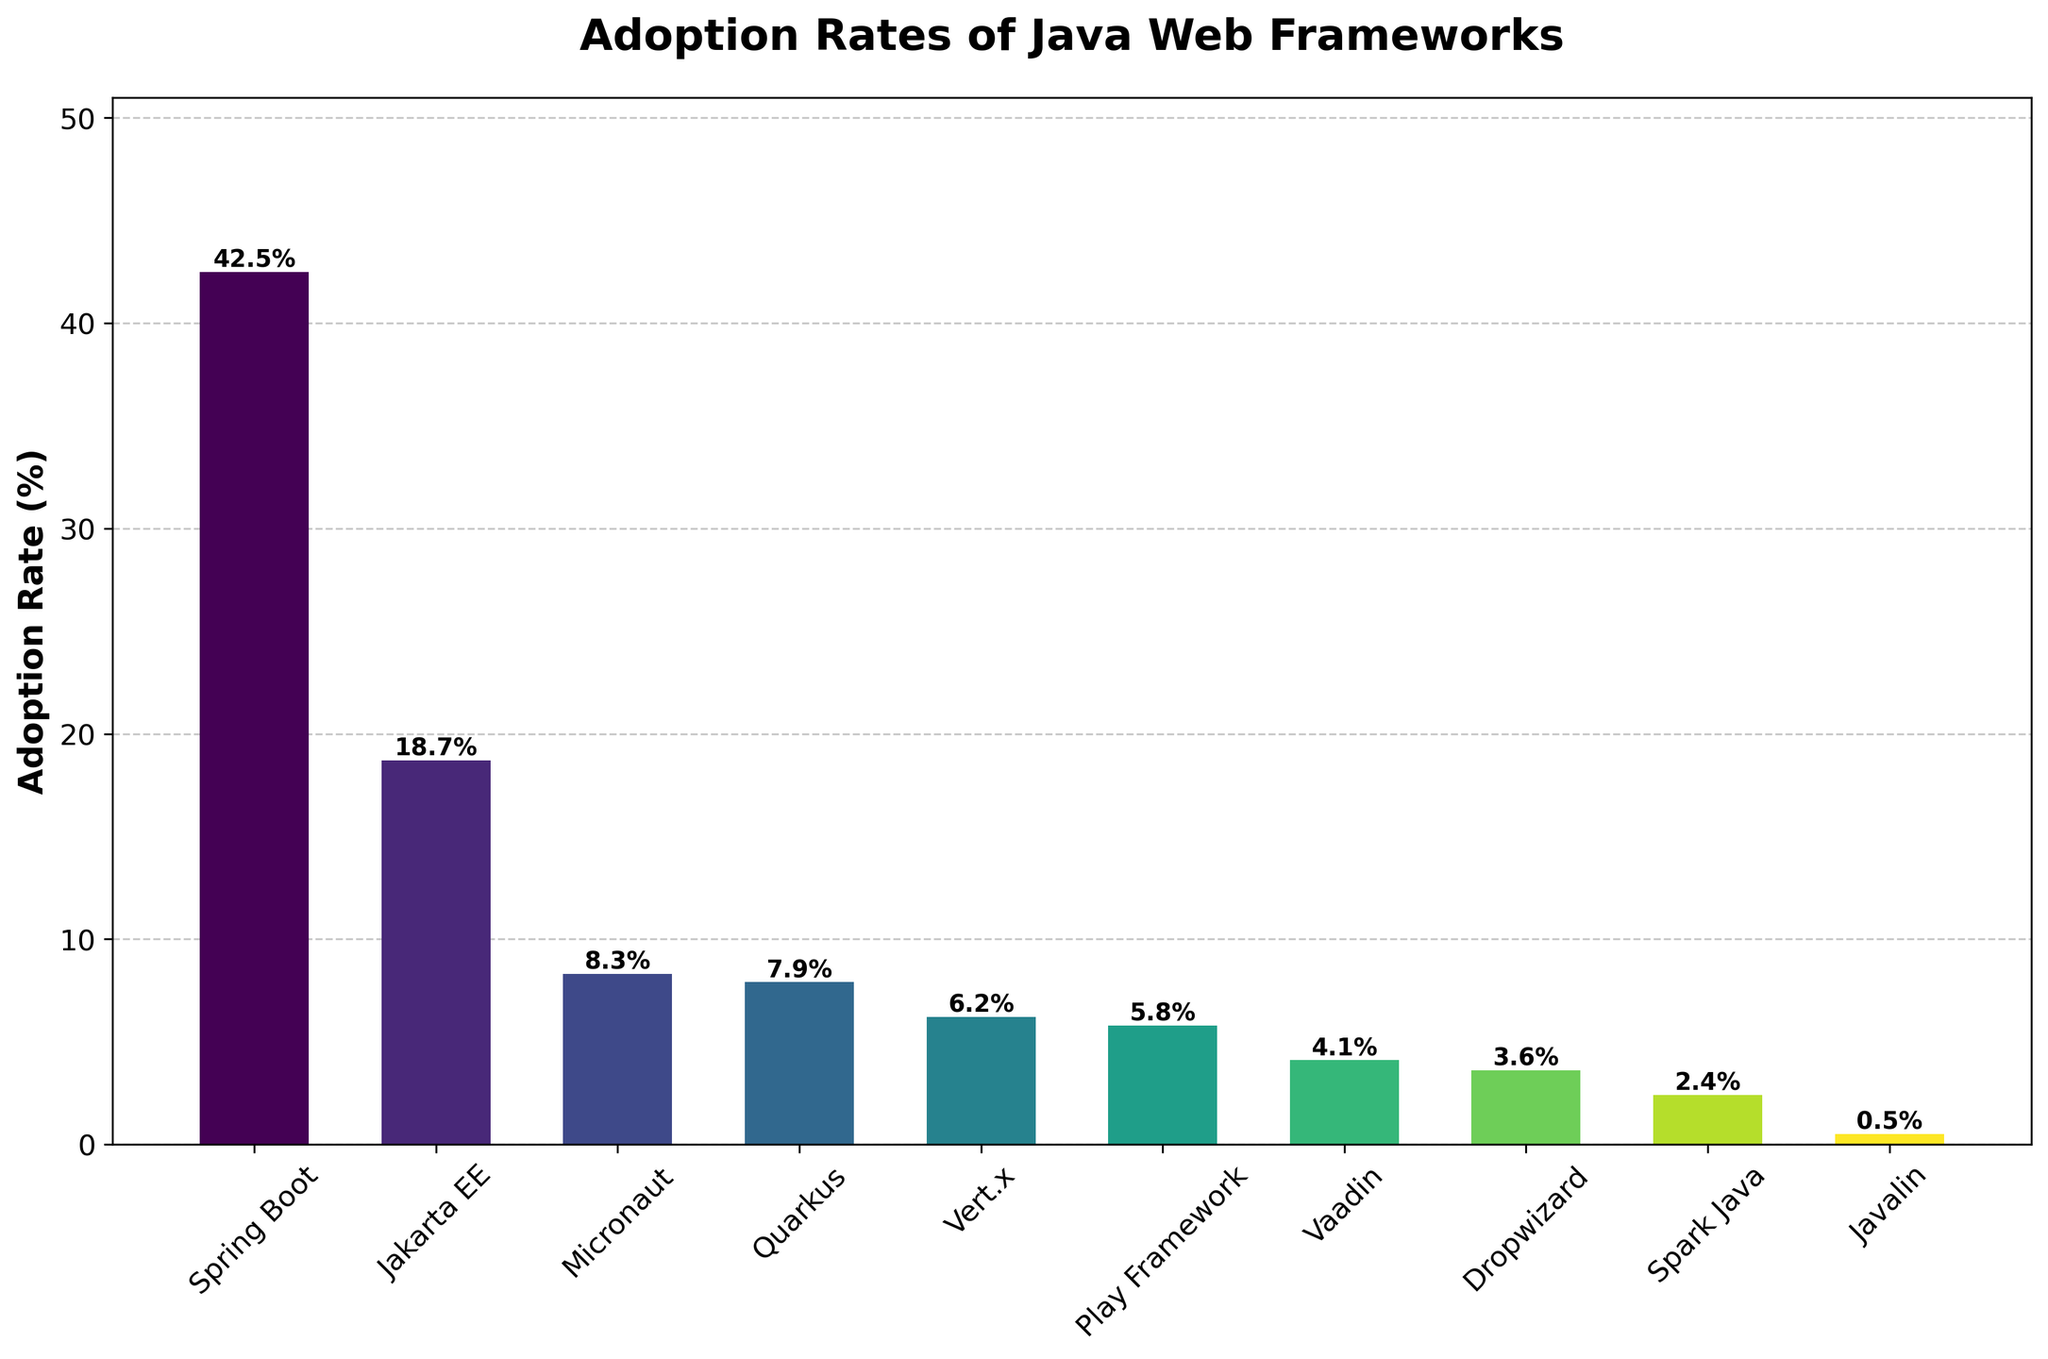What's the adoption rate of Spring Boot? Spring Boot has the tallest bar in the chart. The label on top of the Spring Boot bar indicates an adoption rate of 42.5%.
Answer: 42.5% Which framework has the lowest adoption rate? The shortest bar corresponds to Javalin, and the label on top indicates an adoption rate of 0.5%.
Answer: Javalin How much higher is Spring Boot’s adoption rate compared to Quarkus? Spring Boot has an adoption rate of 42.5%, while Quarkus has 7.9%. The difference is 42.5% - 7.9% = 34.6%.
Answer: 34.6% What is the average adoption rate of the frameworks? Sum all adoption rates (42.5 + 18.7 + 8.3 + 7.9 + 6.2 + 5.8 + 4.1 + 3.6 + 2.4 + 0.5 = 100), then divide by the number of frameworks (10). So, 100 / 10 = 10%.
Answer: 10% Which frameworks have an adoption rate less than 5%? The bars corresponding to Vaadin, Dropwizard, Spark Java, and Javalin have adoption rates of 4.1%, 3.6%, 2.4%, and 0.5% respectively, all below 5%.
Answer: Vaadin, Dropwizard, Spark Java, Javalin Are there more frameworks with adoption rates above or below the average adoption rate? The average adoption rate is 10%. Frameworks above this average are Spring Boot and Jakarta EE, while the others fall below. Count: above (2), below (8).
Answer: Below What's the combined adoption rate of Micronaut, Quarkus, and Vert.x? The adoption rates are 8.3% (Micronaut), 7.9% (Quarkus), and 6.2% (Vert.x). Sum: 8.3 + 7.9 + 6.2 = 22.4%.
Answer: 22.4% Which framework has an adoption rate closest to 5%? Play Framework has an adoption rate of 5.8%, which is closest to 5%.
Answer: Play Framework Between Vaadin and Dropwizard, which one has a higher adoption rate and by how much? Vaadin has an adoption rate of 4.1%, while Dropwizard has 3.6%. The difference is 4.1% - 3.6% = 0.5%.
Answer: Vaadin by 0.5% What is the visual difference between the Spring Boot and Javalin bars? Spring Boot's bar is the tallest, with 42.5% adoption, and is in a bright color at the start of the viridis color map. Javalin's bar is the shortest, with 0.5% adoption, and is in a dark color at the end of the color map.
Answer: Tallest vs. shortest, bright vs. dark color 